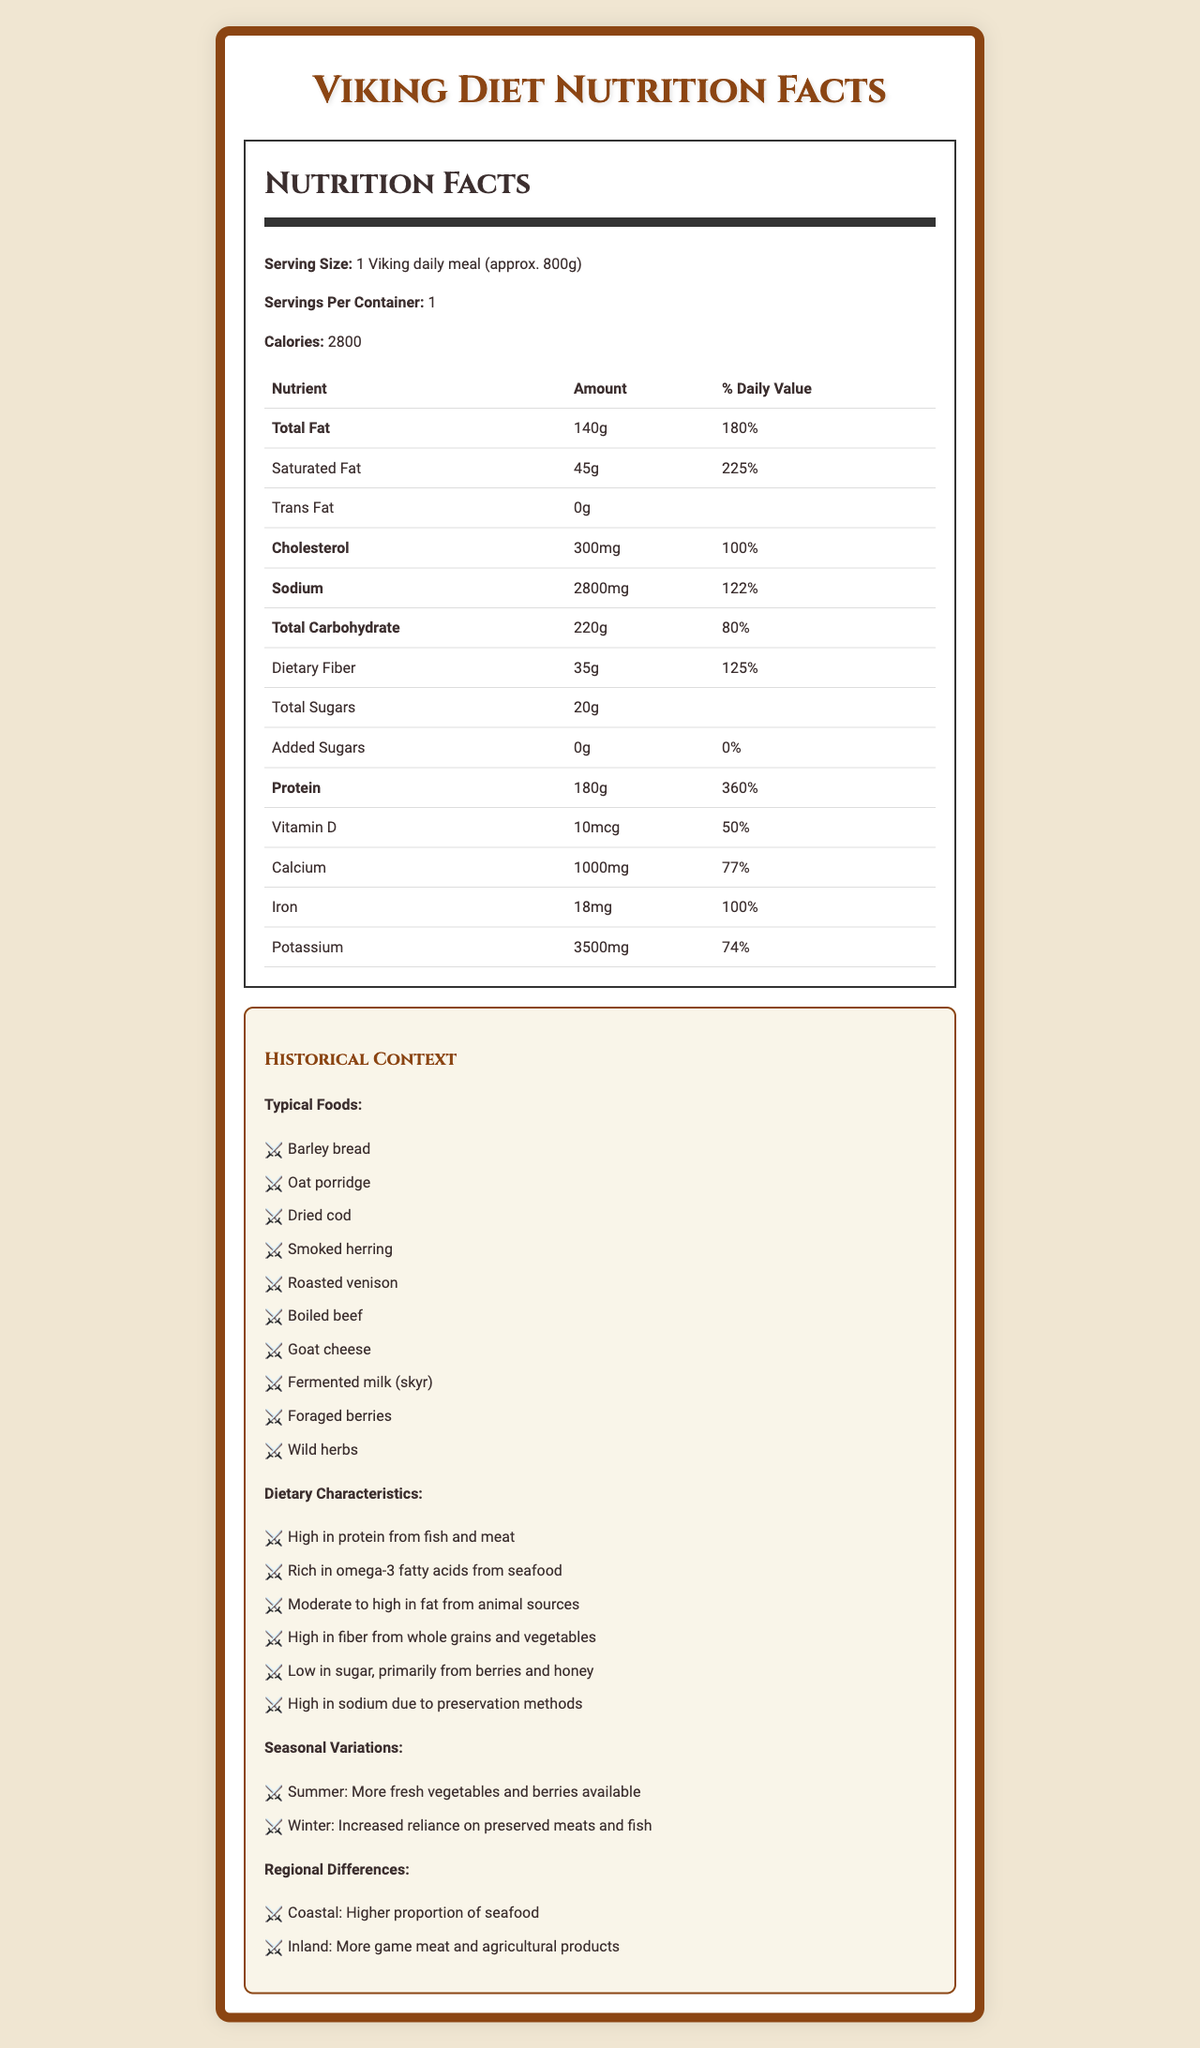what is the serving size? The serving size is mentioned under "Serving Size" in the document.
Answer: 1 Viking daily meal (approx. 800g) how many calories are there per serving? The calories per serving are listed directly in the document under "Calories".
Answer: 2800 calories how much total fat does the Viking diet meal contain? It is specified under "Total Fat" in the nutrition label section.
Answer: 140g which nutrient has the highest daily value percentage? By looking at the percentage daily values in the document, protein has the highest daily value at 360%.
Answer: Protein (360%) how much dietary fiber is in one serving of the Viking diet meal? The amount of dietary fiber is listed under "Dietary Fiber" in the nutrition label section.
Answer: 35g what are some typical foods mentioned in the Viking diet? These foods are listed under "Typical Foods" in the historical context section.
Answer: Barley bread, Oat porridge, Dried cod, Smoked herring, Roasted venison, Boiled beef, Goat cheese, Fermented milk (skyr), Foraged berries, Wild herbs which component has the highest amount listed in milligrams? A. Cholesterol B. Sodium C. Potassium D. Iron By checking the amounts listed in milligrams, potassium has the highest amount at 3500mg.
Answer: C. Potassium which of the following variations affect the Viking diet? I. Seasonal variations II. Regional differences III. Preservation techniques A. I only B. I and II only C. I, II, and III D. II and III only The document mentions seasonal variations and regional differences but does not directly discuss preservation techniques as variations.
Answer: B. I and II only is the Viking diet high in sugar? The document states that the diet is "Low in sugar, primarily from berries and honey."
Answer: No does the nutrition label indicate any trans fat presence? The amount of trans fat listed is 0g.
Answer: No summarize the nutrition facts and historical context provided in the document. The answer encapsulates both the nutrition facts and historical context sections, providing a comprehensive summary of the entire document.
Answer: The document outlines the nutrition facts of a typical daily Viking meal, which is high in calories, fats, proteins, sodium, and dietary fiber. It details typical Viking foods like barley bread, dried cod, and roasted venison. It explains that the diet is high in protein, omega-3 fatty acids, and fiber while being low in sugars. Seasonal variations and regional differences also influence the diet, such as more fresh vegetables in summer and more preserved foods in winter. The document also discusses potential museum immersive experience ideas, educational objectives, challenges, and ethical considerations for presenting this information. why did the Vikings have high sodium levels in their diet? The historical context states that the Viking diet was high in sodium due to the methods of food preservation they used.
Answer: Due to preservation methods how many different types of historical foods are listed in the document? By counting the items under "Typical Foods", there are 10 different types listed.
Answer: 10 what is the proportion of seafood in the Viking diet for coastal regions compared to inland regions? The document mentions that coastal regions had a higher proportion of seafood compared to inland regions.
Answer: Higher proportion in coastal regions does the document provide specific modern food safety standards? The document mentions ensuring historical accuracy while meeting modern food safety standards, but it does not provide specific details on these standards.
Answer: Cannot be determined 